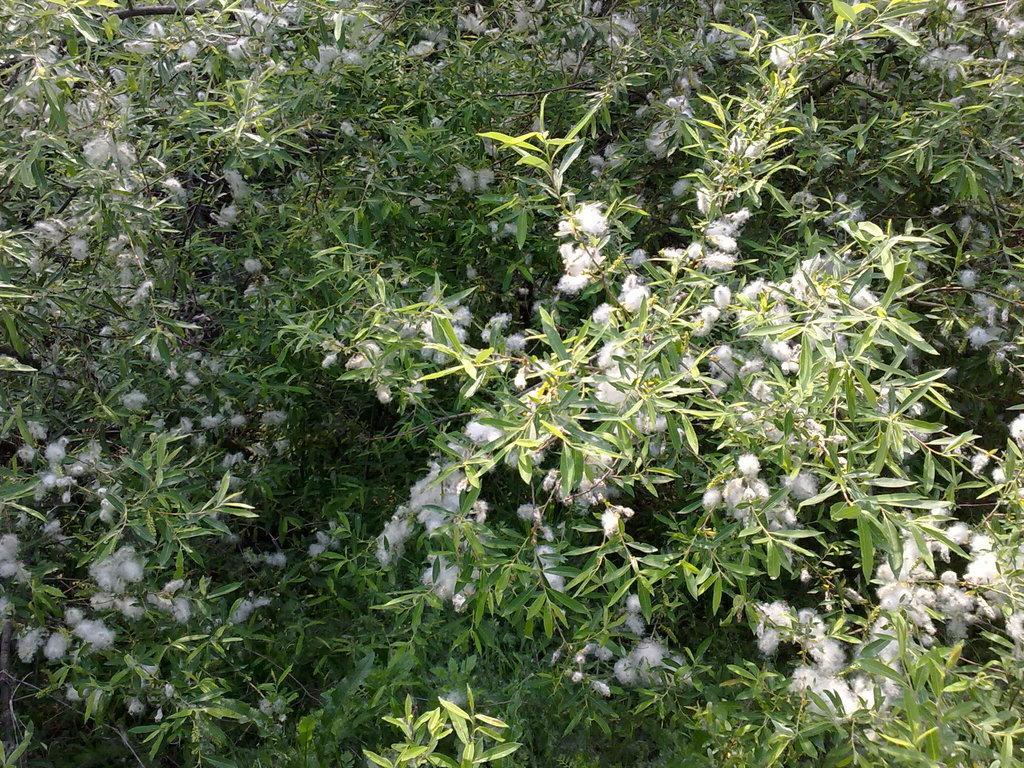How would you summarize this image in a sentence or two? In this image there are plants having flowers and leaves. 